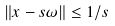Convert formula to latex. <formula><loc_0><loc_0><loc_500><loc_500>\| x - s \omega \| \leq 1 / s</formula> 